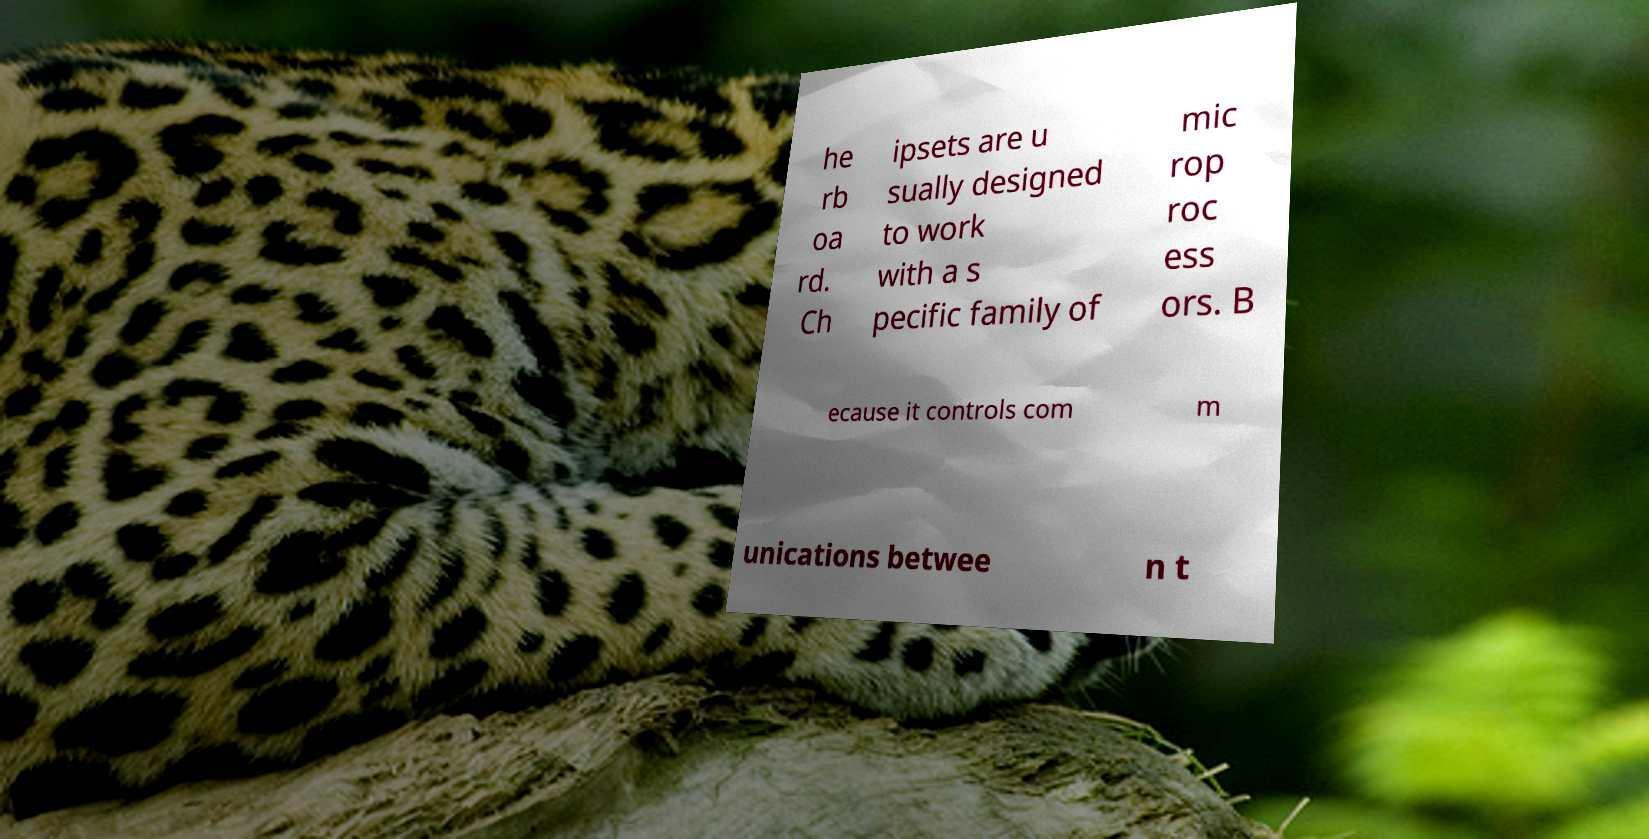I need the written content from this picture converted into text. Can you do that? he rb oa rd. Ch ipsets are u sually designed to work with a s pecific family of mic rop roc ess ors. B ecause it controls com m unications betwee n t 